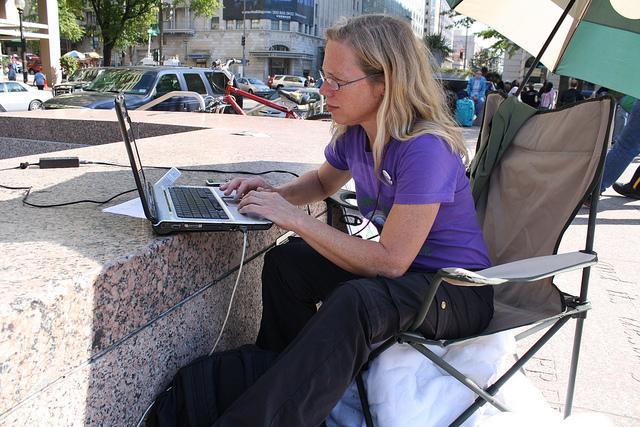Why is she working here? Please explain your reasoning. power source. There is a common electrical power outlet located in the wall that the woman has set the computer on. 